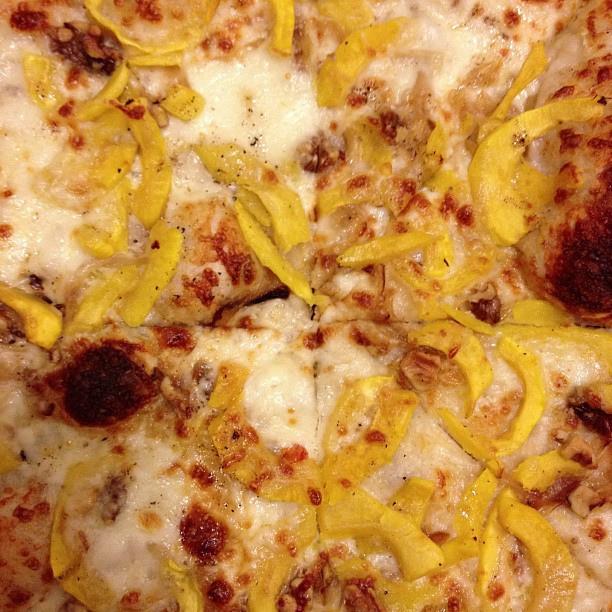Has this dish already been cooked?
Short answer required. Yes. What food is this?
Answer briefly. Pizza. What toppings are on this pizza?
Give a very brief answer. Peppers. 